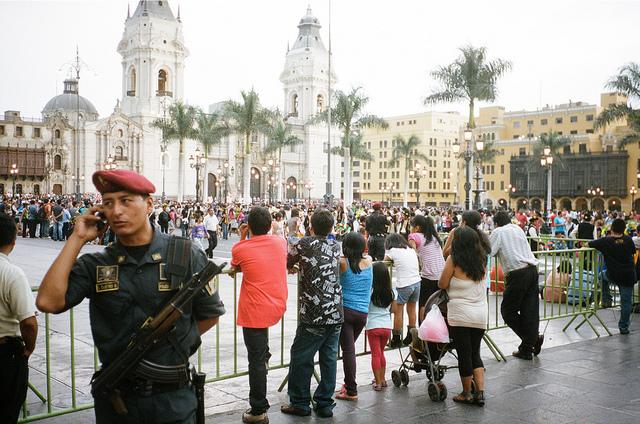Who is talking on the phone?
Write a very short answer. Soldier. Is there a stroller in this photo?
Give a very brief answer. Yes. Are these people tourists?
Keep it brief. Yes. 